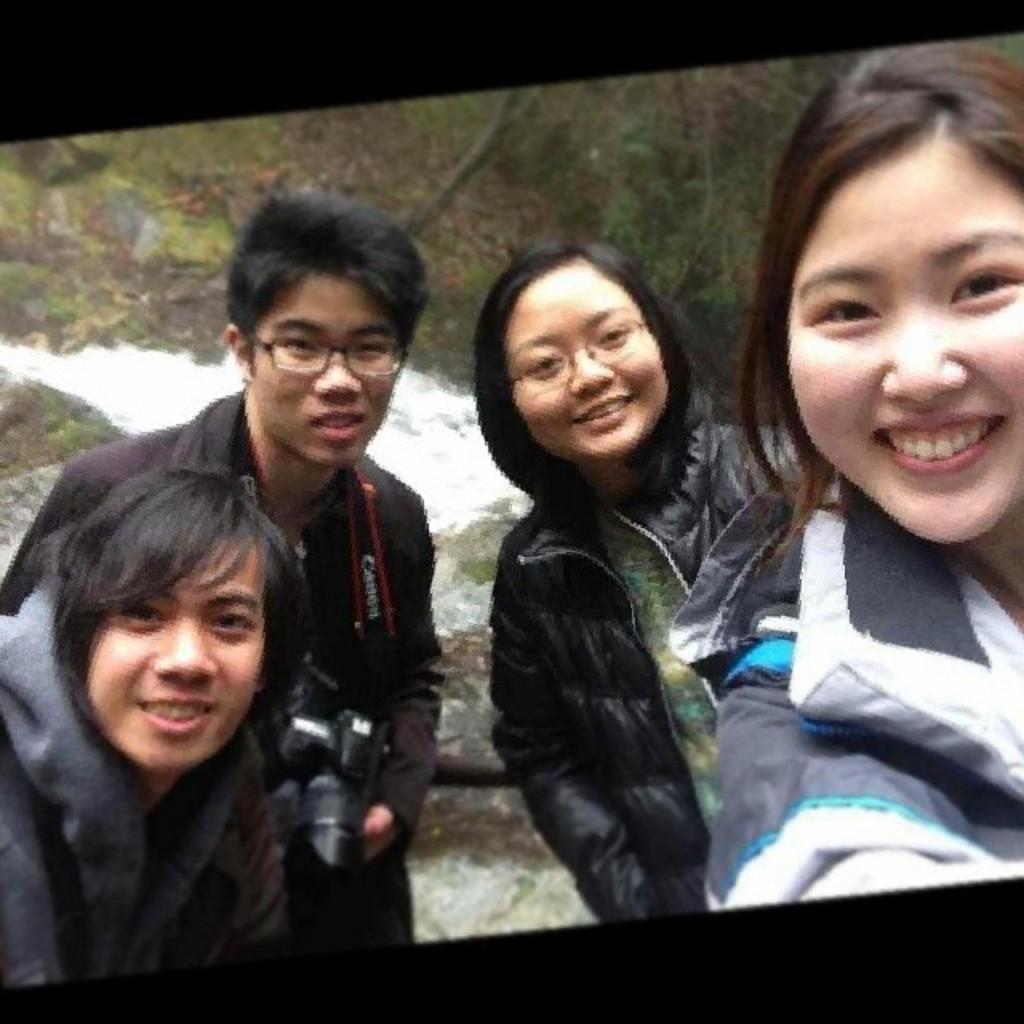Please provide a concise description of this image. In this image I can see on the left side a man is standing and also holding the camera. On the right side two girls are standing and smiling, at the top there are trees. 